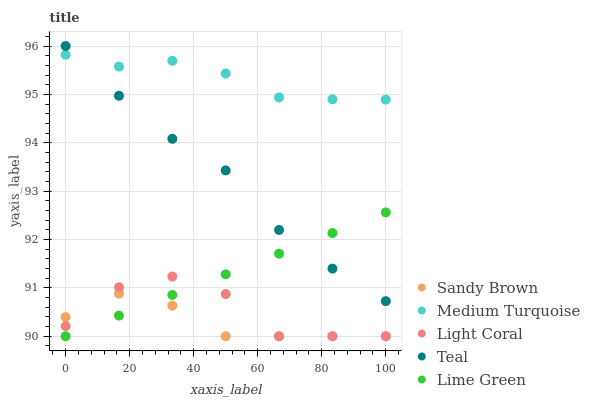Does Sandy Brown have the minimum area under the curve?
Answer yes or no. Yes. Does Medium Turquoise have the maximum area under the curve?
Answer yes or no. Yes. Does Lime Green have the minimum area under the curve?
Answer yes or no. No. Does Lime Green have the maximum area under the curve?
Answer yes or no. No. Is Lime Green the smoothest?
Answer yes or no. Yes. Is Light Coral the roughest?
Answer yes or no. Yes. Is Sandy Brown the smoothest?
Answer yes or no. No. Is Sandy Brown the roughest?
Answer yes or no. No. Does Light Coral have the lowest value?
Answer yes or no. Yes. Does Teal have the lowest value?
Answer yes or no. No. Does Teal have the highest value?
Answer yes or no. Yes. Does Lime Green have the highest value?
Answer yes or no. No. Is Sandy Brown less than Teal?
Answer yes or no. Yes. Is Teal greater than Light Coral?
Answer yes or no. Yes. Does Sandy Brown intersect Light Coral?
Answer yes or no. Yes. Is Sandy Brown less than Light Coral?
Answer yes or no. No. Is Sandy Brown greater than Light Coral?
Answer yes or no. No. Does Sandy Brown intersect Teal?
Answer yes or no. No. 